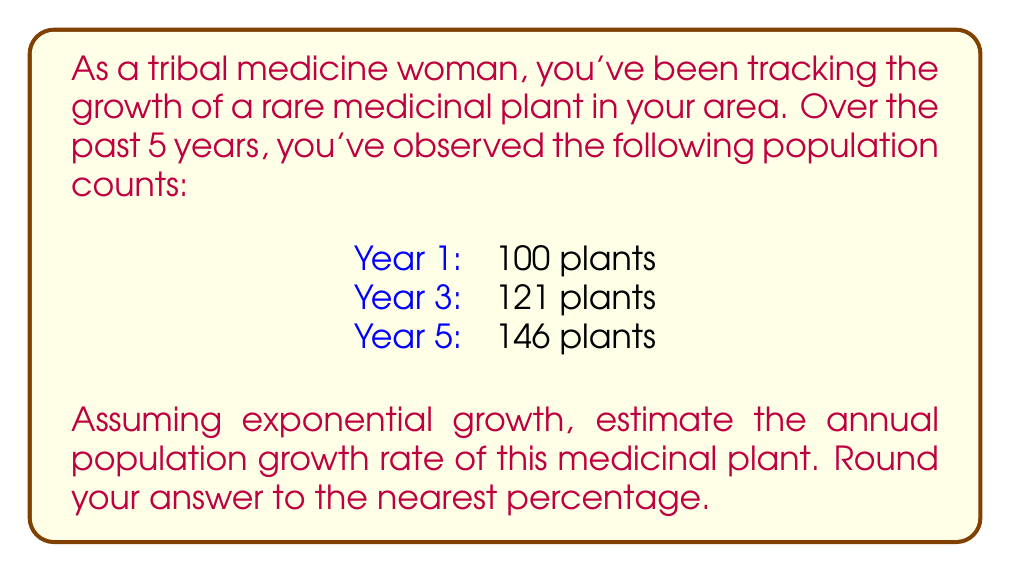Provide a solution to this math problem. To solve this problem, we'll use the exponential growth formula:

$$P(t) = P_0 \cdot (1 + r)^t$$

Where:
$P(t)$ is the population at time $t$
$P_0$ is the initial population
$r$ is the annual growth rate
$t$ is the time in years

We'll use the data from Year 1 and Year 5:

$P_0 = 100$ (initial population)
$P(t) = 146$ (population after 4 years)
$t = 4$ (time elapsed)

Substituting these values into the formula:

$$146 = 100 \cdot (1 + r)^4$$

Dividing both sides by 100:

$$1.46 = (1 + r)^4$$

Taking the fourth root of both sides:

$$\sqrt[4]{1.46} = 1 + r$$

$$1.0986 = 1 + r$$

Subtracting 1 from both sides:

$$r = 0.0986$$

Converting to a percentage:

$$r = 0.0986 \times 100\% = 9.86\%$$

Rounding to the nearest percentage:

$$r \approx 10\%$$
Answer: The estimated annual population growth rate of the medicinal plant is approximately 10%. 